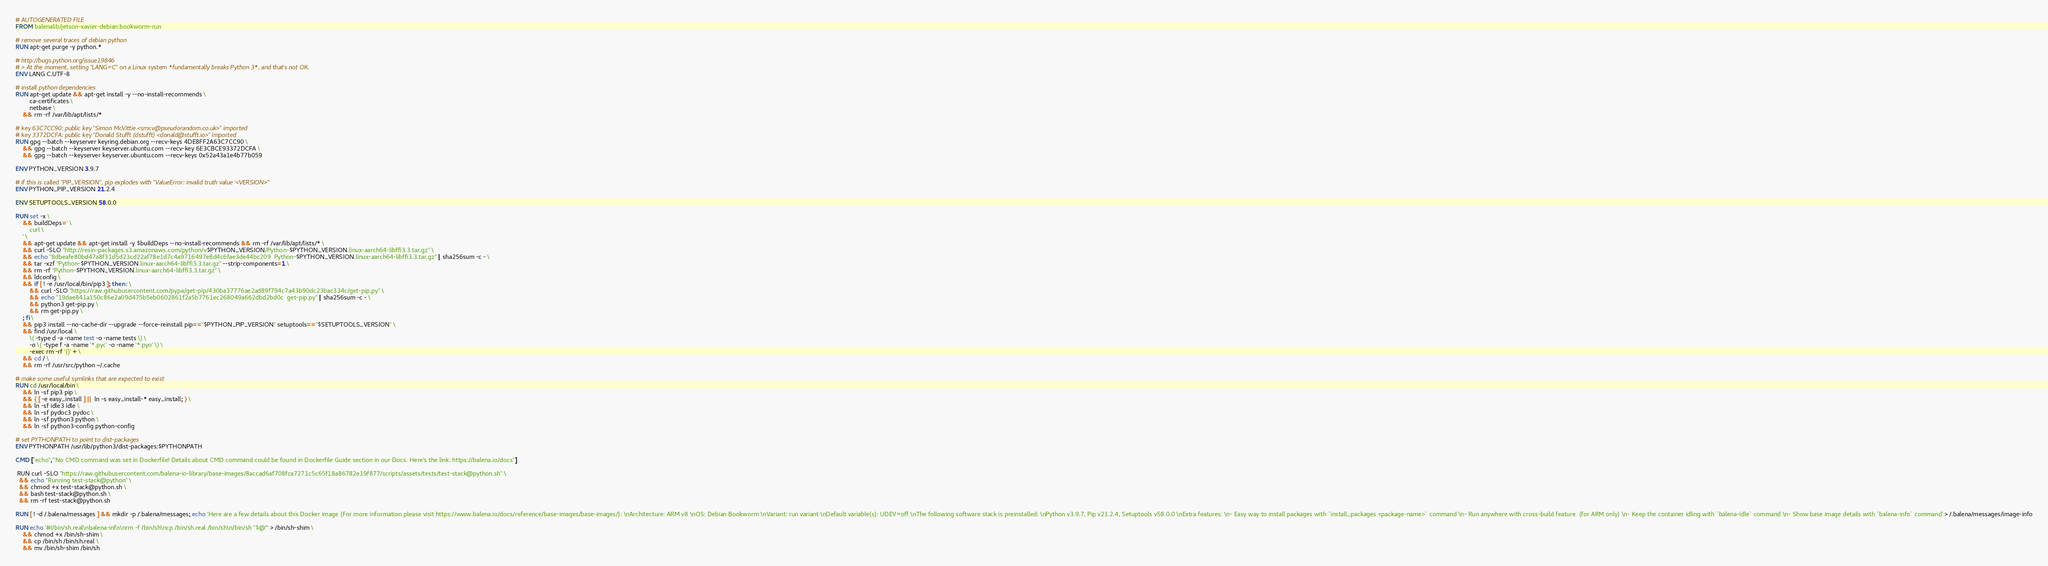<code> <loc_0><loc_0><loc_500><loc_500><_Dockerfile_># AUTOGENERATED FILE
FROM balenalib/jetson-xavier-debian:bookworm-run

# remove several traces of debian python
RUN apt-get purge -y python.*

# http://bugs.python.org/issue19846
# > At the moment, setting "LANG=C" on a Linux system *fundamentally breaks Python 3*, and that's not OK.
ENV LANG C.UTF-8

# install python dependencies
RUN apt-get update && apt-get install -y --no-install-recommends \
		ca-certificates \
		netbase \
	&& rm -rf /var/lib/apt/lists/*

# key 63C7CC90: public key "Simon McVittie <smcv@pseudorandom.co.uk>" imported
# key 3372DCFA: public key "Donald Stufft (dstufft) <donald@stufft.io>" imported
RUN gpg --batch --keyserver keyring.debian.org --recv-keys 4DE8FF2A63C7CC90 \
	&& gpg --batch --keyserver keyserver.ubuntu.com --recv-key 6E3CBCE93372DCFA \
	&& gpg --batch --keyserver keyserver.ubuntu.com --recv-keys 0x52a43a1e4b77b059

ENV PYTHON_VERSION 3.9.7

# if this is called "PIP_VERSION", pip explodes with "ValueError: invalid truth value '<VERSION>'"
ENV PYTHON_PIP_VERSION 21.2.4

ENV SETUPTOOLS_VERSION 58.0.0

RUN set -x \
	&& buildDeps=' \
		curl \
	' \
	&& apt-get update && apt-get install -y $buildDeps --no-install-recommends && rm -rf /var/lib/apt/lists/* \
	&& curl -SLO "http://resin-packages.s3.amazonaws.com/python/v$PYTHON_VERSION/Python-$PYTHON_VERSION.linux-aarch64-libffi3.3.tar.gz" \
	&& echo "8dbeafe80bd47a8f31d5d23cd22af78e1d7c4a9716497e8d4c6fae3de44bc209  Python-$PYTHON_VERSION.linux-aarch64-libffi3.3.tar.gz" | sha256sum -c - \
	&& tar -xzf "Python-$PYTHON_VERSION.linux-aarch64-libffi3.3.tar.gz" --strip-components=1 \
	&& rm -rf "Python-$PYTHON_VERSION.linux-aarch64-libffi3.3.tar.gz" \
	&& ldconfig \
	&& if [ ! -e /usr/local/bin/pip3 ]; then : \
		&& curl -SLO "https://raw.githubusercontent.com/pypa/get-pip/430ba37776ae2ad89f794c7a43b90dc23bac334c/get-pip.py" \
		&& echo "19dae841a150c86e2a09d475b5eb0602861f2a5b7761ec268049a662dbd2bd0c  get-pip.py" | sha256sum -c - \
		&& python3 get-pip.py \
		&& rm get-pip.py \
	; fi \
	&& pip3 install --no-cache-dir --upgrade --force-reinstall pip=="$PYTHON_PIP_VERSION" setuptools=="$SETUPTOOLS_VERSION" \
	&& find /usr/local \
		\( -type d -a -name test -o -name tests \) \
		-o \( -type f -a -name '*.pyc' -o -name '*.pyo' \) \
		-exec rm -rf '{}' + \
	&& cd / \
	&& rm -rf /usr/src/python ~/.cache

# make some useful symlinks that are expected to exist
RUN cd /usr/local/bin \
	&& ln -sf pip3 pip \
	&& { [ -e easy_install ] || ln -s easy_install-* easy_install; } \
	&& ln -sf idle3 idle \
	&& ln -sf pydoc3 pydoc \
	&& ln -sf python3 python \
	&& ln -sf python3-config python-config

# set PYTHONPATH to point to dist-packages
ENV PYTHONPATH /usr/lib/python3/dist-packages:$PYTHONPATH

CMD ["echo","'No CMD command was set in Dockerfile! Details about CMD command could be found in Dockerfile Guide section in our Docs. Here's the link: https://balena.io/docs"]

 RUN curl -SLO "https://raw.githubusercontent.com/balena-io-library/base-images/8accad6af708fca7271c5c65f18a86782e19f877/scripts/assets/tests/test-stack@python.sh" \
  && echo "Running test-stack@python" \
  && chmod +x test-stack@python.sh \
  && bash test-stack@python.sh \
  && rm -rf test-stack@python.sh 

RUN [ ! -d /.balena/messages ] && mkdir -p /.balena/messages; echo 'Here are a few details about this Docker image (For more information please visit https://www.balena.io/docs/reference/base-images/base-images/): \nArchitecture: ARM v8 \nOS: Debian Bookworm \nVariant: run variant \nDefault variable(s): UDEV=off \nThe following software stack is preinstalled: \nPython v3.9.7, Pip v21.2.4, Setuptools v58.0.0 \nExtra features: \n- Easy way to install packages with `install_packages <package-name>` command \n- Run anywhere with cross-build feature  (for ARM only) \n- Keep the container idling with `balena-idle` command \n- Show base image details with `balena-info` command' > /.balena/messages/image-info

RUN echo '#!/bin/sh.real\nbalena-info\nrm -f /bin/sh\ncp /bin/sh.real /bin/sh\n/bin/sh "$@"' > /bin/sh-shim \
	&& chmod +x /bin/sh-shim \
	&& cp /bin/sh /bin/sh.real \
	&& mv /bin/sh-shim /bin/sh</code> 